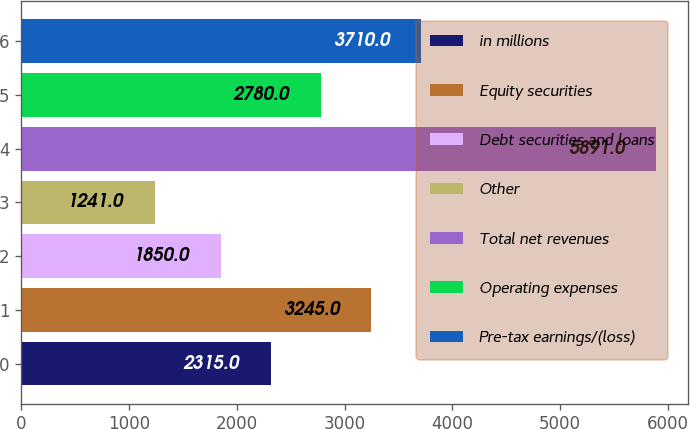<chart> <loc_0><loc_0><loc_500><loc_500><bar_chart><fcel>in millions<fcel>Equity securities<fcel>Debt securities and loans<fcel>Other<fcel>Total net revenues<fcel>Operating expenses<fcel>Pre-tax earnings/(loss)<nl><fcel>2315<fcel>3245<fcel>1850<fcel>1241<fcel>5891<fcel>2780<fcel>3710<nl></chart> 